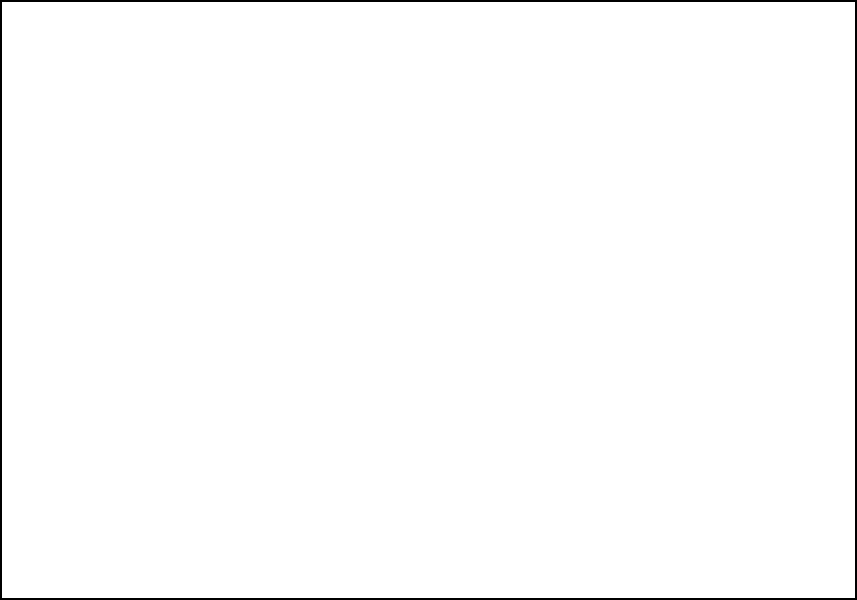In this complex audio mixing board schematic, identify the correct signal path for Input 3. Which output channel does it connect to? To identify the correct signal path for Input 3 and determine its output channel, let's follow these steps:

1. Locate Input 3 on the left side of the mixing board schematic.
2. Trace the signal path from Input 3 through the EQ section.
3. Observe that there are three dashed lines representing correct connections and two dotted lines representing incorrect connections.
4. The dashed line starting from Input 3 (the middle input) passes through the EQ section.
5. Follow this dashed line to see which output channel it connects to on the right side of the board.
6. The dashed line from Input 3 connects to the middle output on the right side.
7. This middle output is labeled as "Out 2".

Therefore, the correct signal path for Input 3 connects to Output 2.
Answer: Output 2 